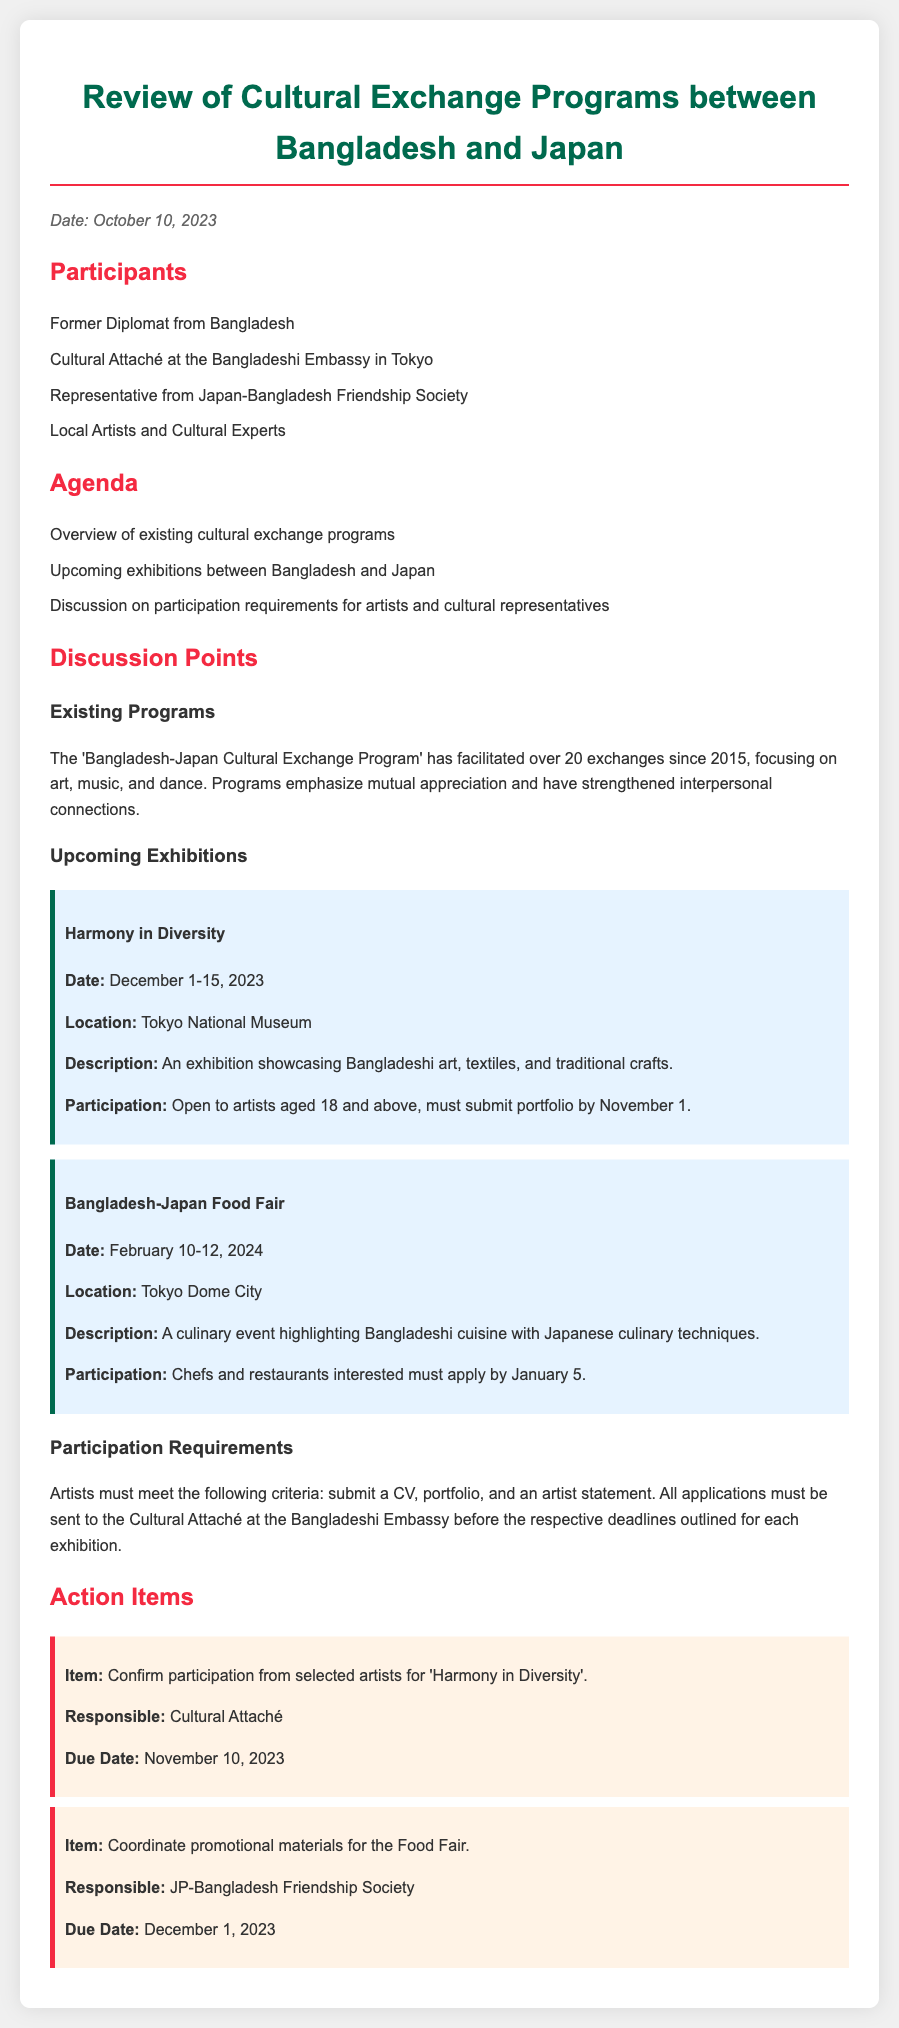What is the date of the meeting? The date of the meeting is specified at the beginning of the document.
Answer: October 10, 2023 How many exchanges has the cultural exchange program facilitated since 2015? The document mentions the number of exchanges that have taken place since 2015.
Answer: over 20 What is the location of the 'Harmony in Diversity' exhibition? The location of the exhibition is provided in the details about the upcoming exhibitions.
Answer: Tokyo National Museum What is the submission deadline for the 'Harmony in Diversity' participation? The document outlines the submission requirements, including deadlines for participation in the exhibitions.
Answer: November 1 Who is responsible for confirming participation from selected artists? The document states who is accountable for specific action items during the meeting.
Answer: Cultural Attaché What dates will the Bangladesh-Japan Food Fair take place? The document lists the dates for upcoming exhibitions, including the Food Fair.
Answer: February 10-12, 2024 What document must artists submit along with their portfolio? The participation requirements mention specific documents required from artists.
Answer: CV What is the theme of the upcoming exhibition held in December 2023? The document includes a brief description for each exhibition, revealing their themes.
Answer: Harmony in Diversity When is the due date for coordinating promotional materials for the Food Fair? The document specifies due dates for various action items discussed in the meeting.
Answer: December 1, 2023 